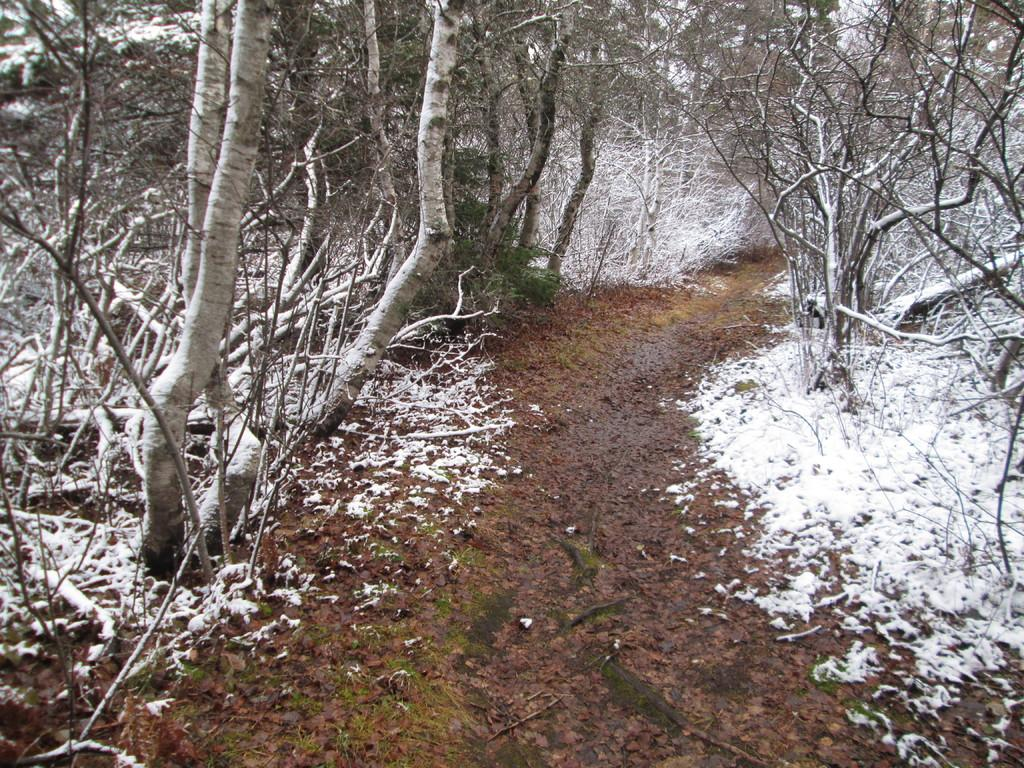What type of vegetation is visible in the image? There are trees in the image. What type of terrain is visible in the image? There is ground visible in the image. What weather condition is depicted in the image? There is snow in the image. Can you tell me where the writer is sitting in the image? There is no writer present in the image. Do you believe that there is a goldfish swimming in the snow in the image? There is no goldfish present in the image. 